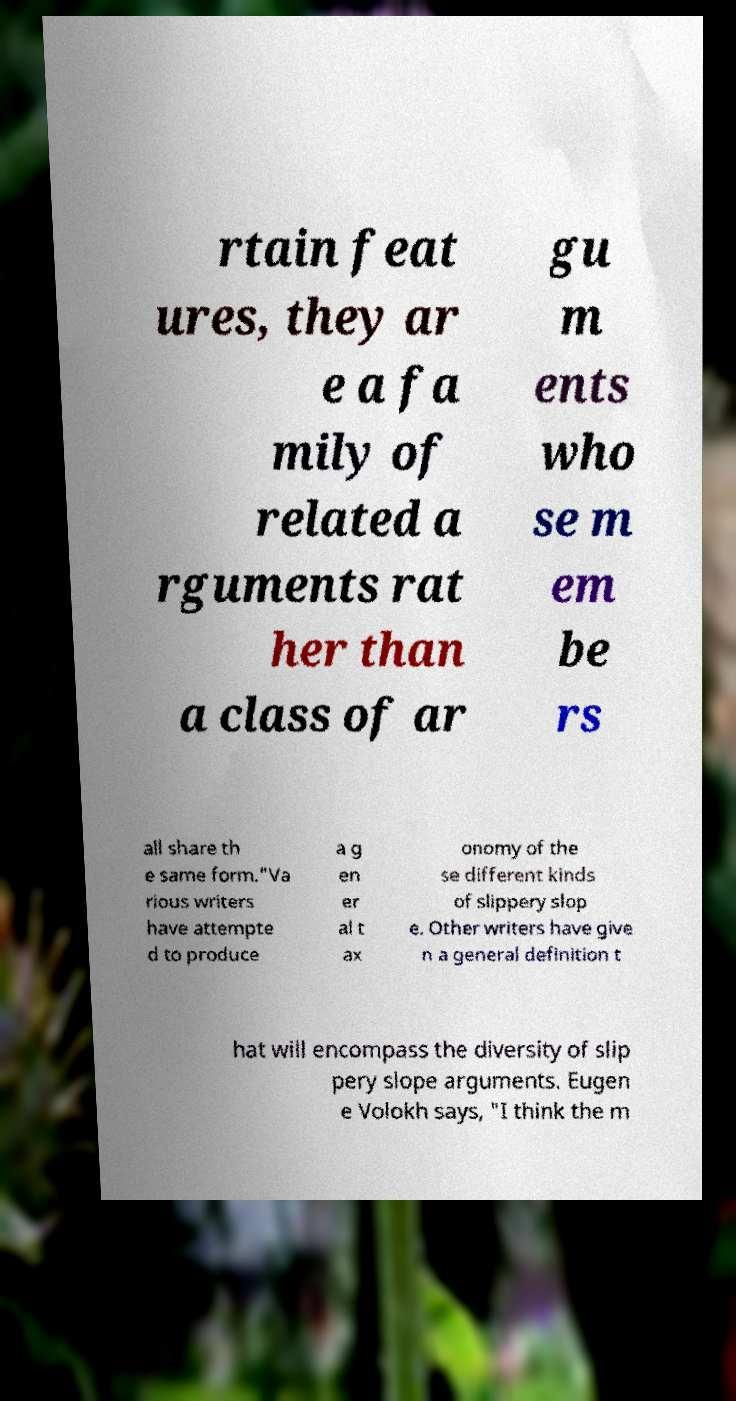I need the written content from this picture converted into text. Can you do that? rtain feat ures, they ar e a fa mily of related a rguments rat her than a class of ar gu m ents who se m em be rs all share th e same form."Va rious writers have attempte d to produce a g en er al t ax onomy of the se different kinds of slippery slop e. Other writers have give n a general definition t hat will encompass the diversity of slip pery slope arguments. Eugen e Volokh says, "I think the m 